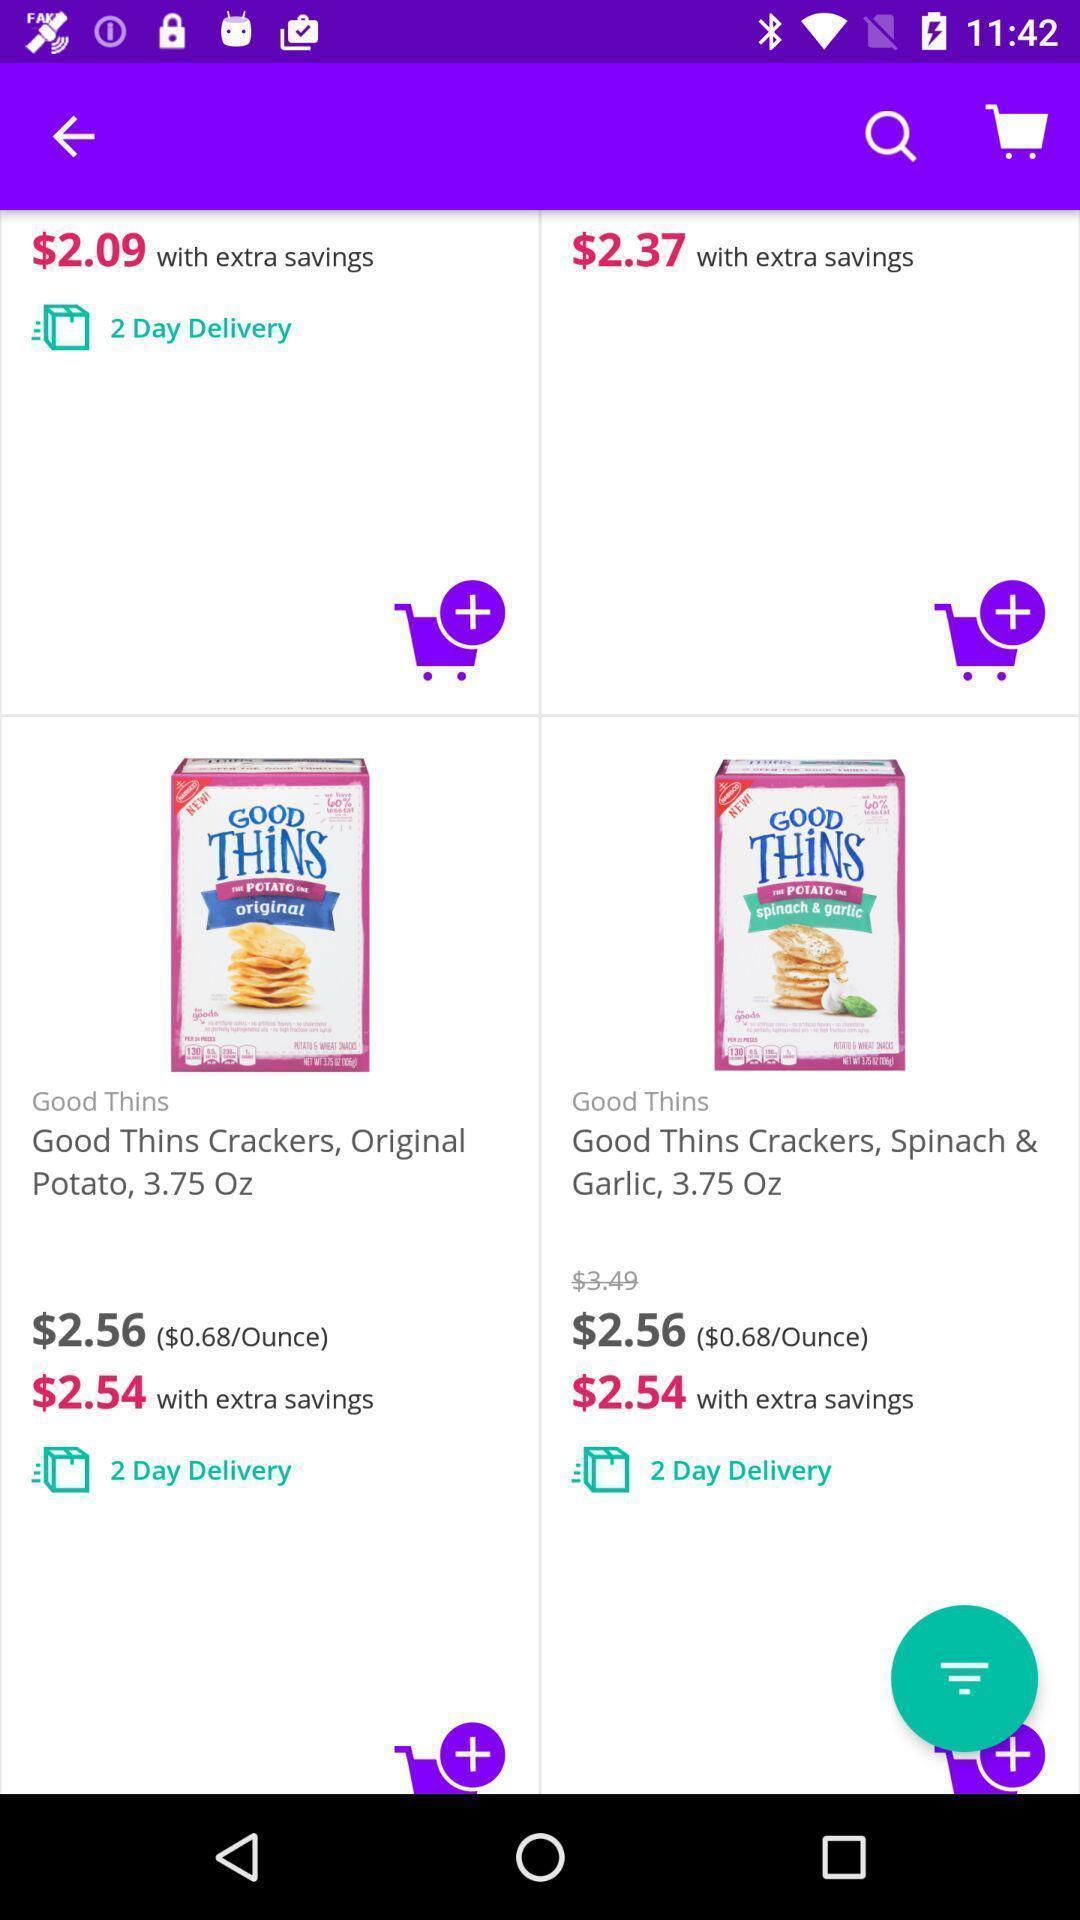Tell me about the visual elements in this screen capture. Window displaying a shopping app. 